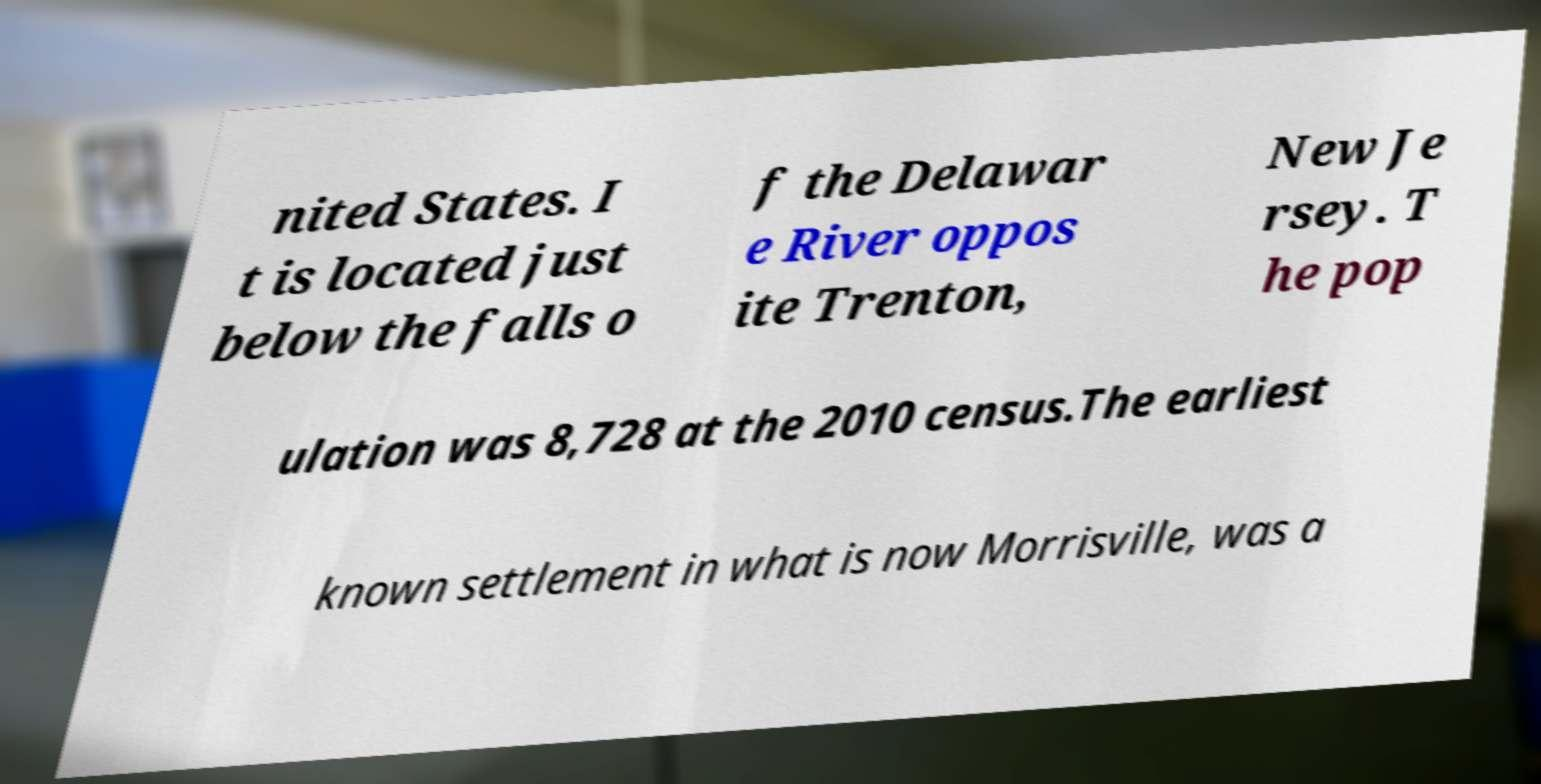Please read and relay the text visible in this image. What does it say? nited States. I t is located just below the falls o f the Delawar e River oppos ite Trenton, New Je rsey. T he pop ulation was 8,728 at the 2010 census.The earliest known settlement in what is now Morrisville, was a 